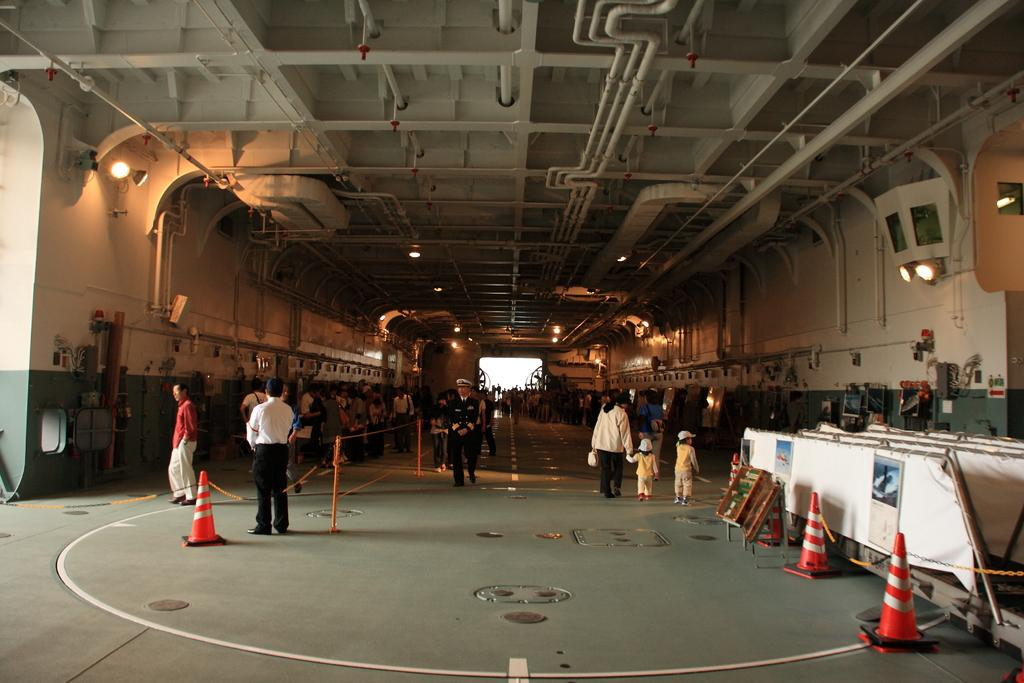How many people are in the image? There are persons standing in the image. What are the people wearing? The persons are wearing clothes. What objects can be seen on the ground in the image? There are divider cones on the ground. What is present on the ceiling in the image? There are lights and pipes on the ceiling. What type of leather material can be seen in the image? There is no leather material present in the image. What is the purpose of the pail in the image? There is no pail present in the image. 